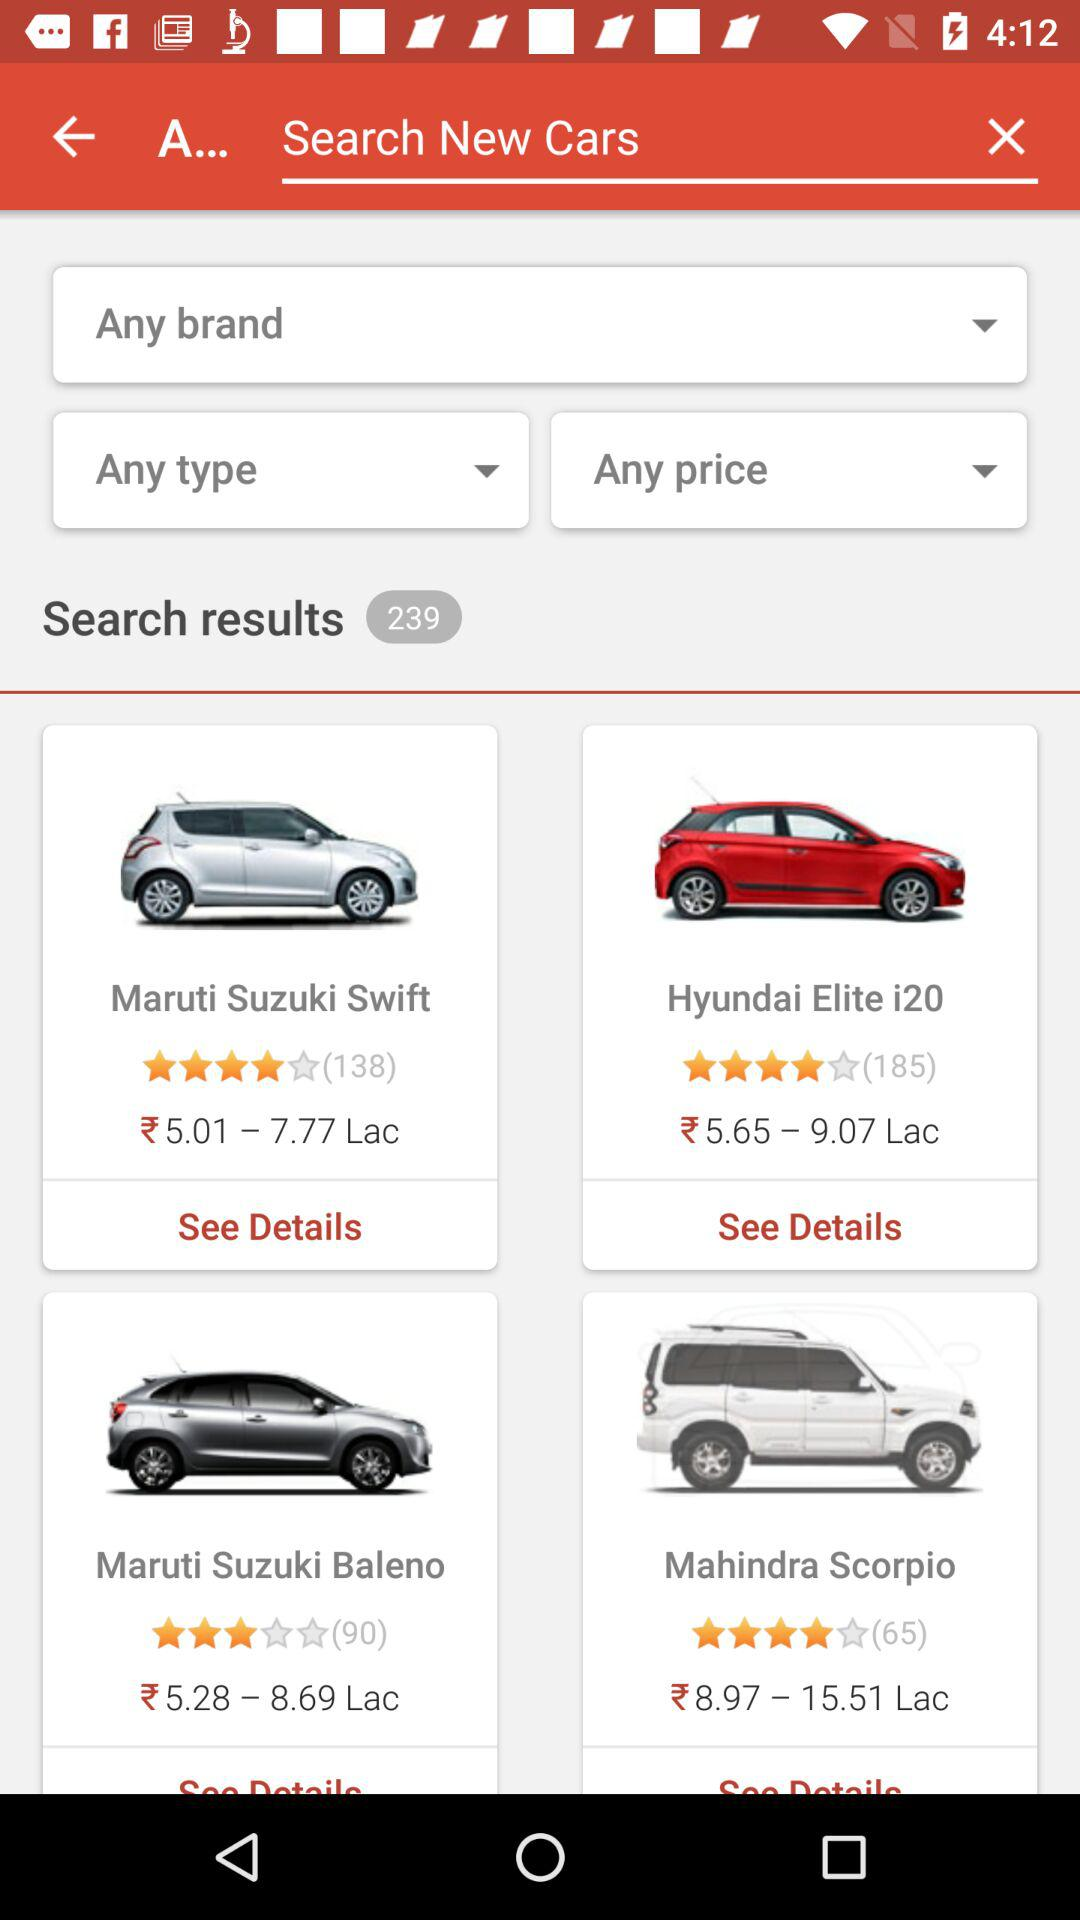What is the price of the Hyundai Elite i20? The price of the Hyundai Elite i20 is between ₹5.65 and ₹9.07 Lakh. 